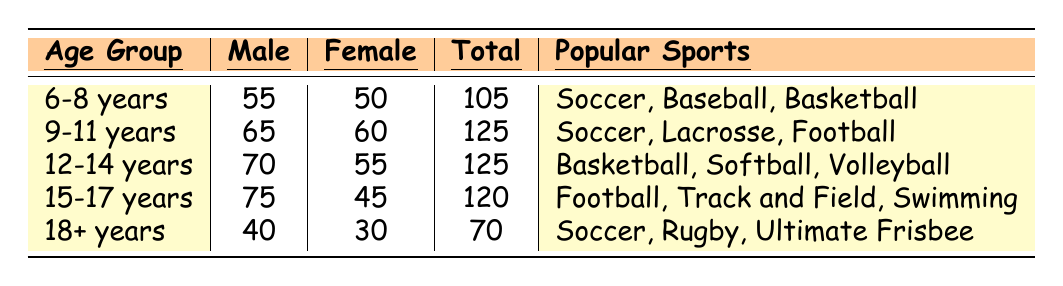What is the total participation for the age group 12-14 years? The table indicates that for the age group 12-14 years, the total participation is shown as 125.
Answer: 125 Which age group has the highest male participation? Looking at the male participation column, the age group 15-17 years has the highest value at 75.
Answer: 75 Is the participation of females higher than males in the 6-8 years age group? In the 6-8 years age group, the female participation is 50 while male participation is 55, meaning females do not have higher participation.
Answer: No What is the difference in total participation between the age groups 9-11 years and 15-17 years? The total participation for 9-11 years is 125 and for 15-17 years is 120. The difference is 125 - 120 = 5.
Answer: 5 What is the average male participation across all age groups listed? The male participation values are 55, 65, 70, 75, and 40. Summing these: 55 + 65 + 70 + 75 + 40 = 305. Dividing this by the number of groups (5) gives an average of 305 / 5 = 61.
Answer: 61 Which sports are popular among 12-14 years old participants? The table lists the popular sports for the 12-14 years age group as Basketball, Softball, and Volleyball.
Answer: Basketball, Softball, Volleyball What is the total male participation for all age groups combined? Adding the male participations: 55 + 65 + 70 + 75 + 40 = 305, provides the total male participation across all age groups.
Answer: 305 In which age group is the female participation lowest? The lowest female participation is found in the 15-17 years age group, which has 45 participants.
Answer: 45 What is the total number of participants for age groups 6-8 years and 18 years and older combined? Total participation for 6-8 years is 105 and for 18 years and older is 70. Adding these together: 105 + 70 = 175.
Answer: 175 Is there a notable decline in male participation from the 12-14 years to the 15-17 years age group? Male participation decreases from 70 (12-14 years) to 75 (15-17 years) indicating there isn't a decline; in fact, it's an increase.
Answer: No 